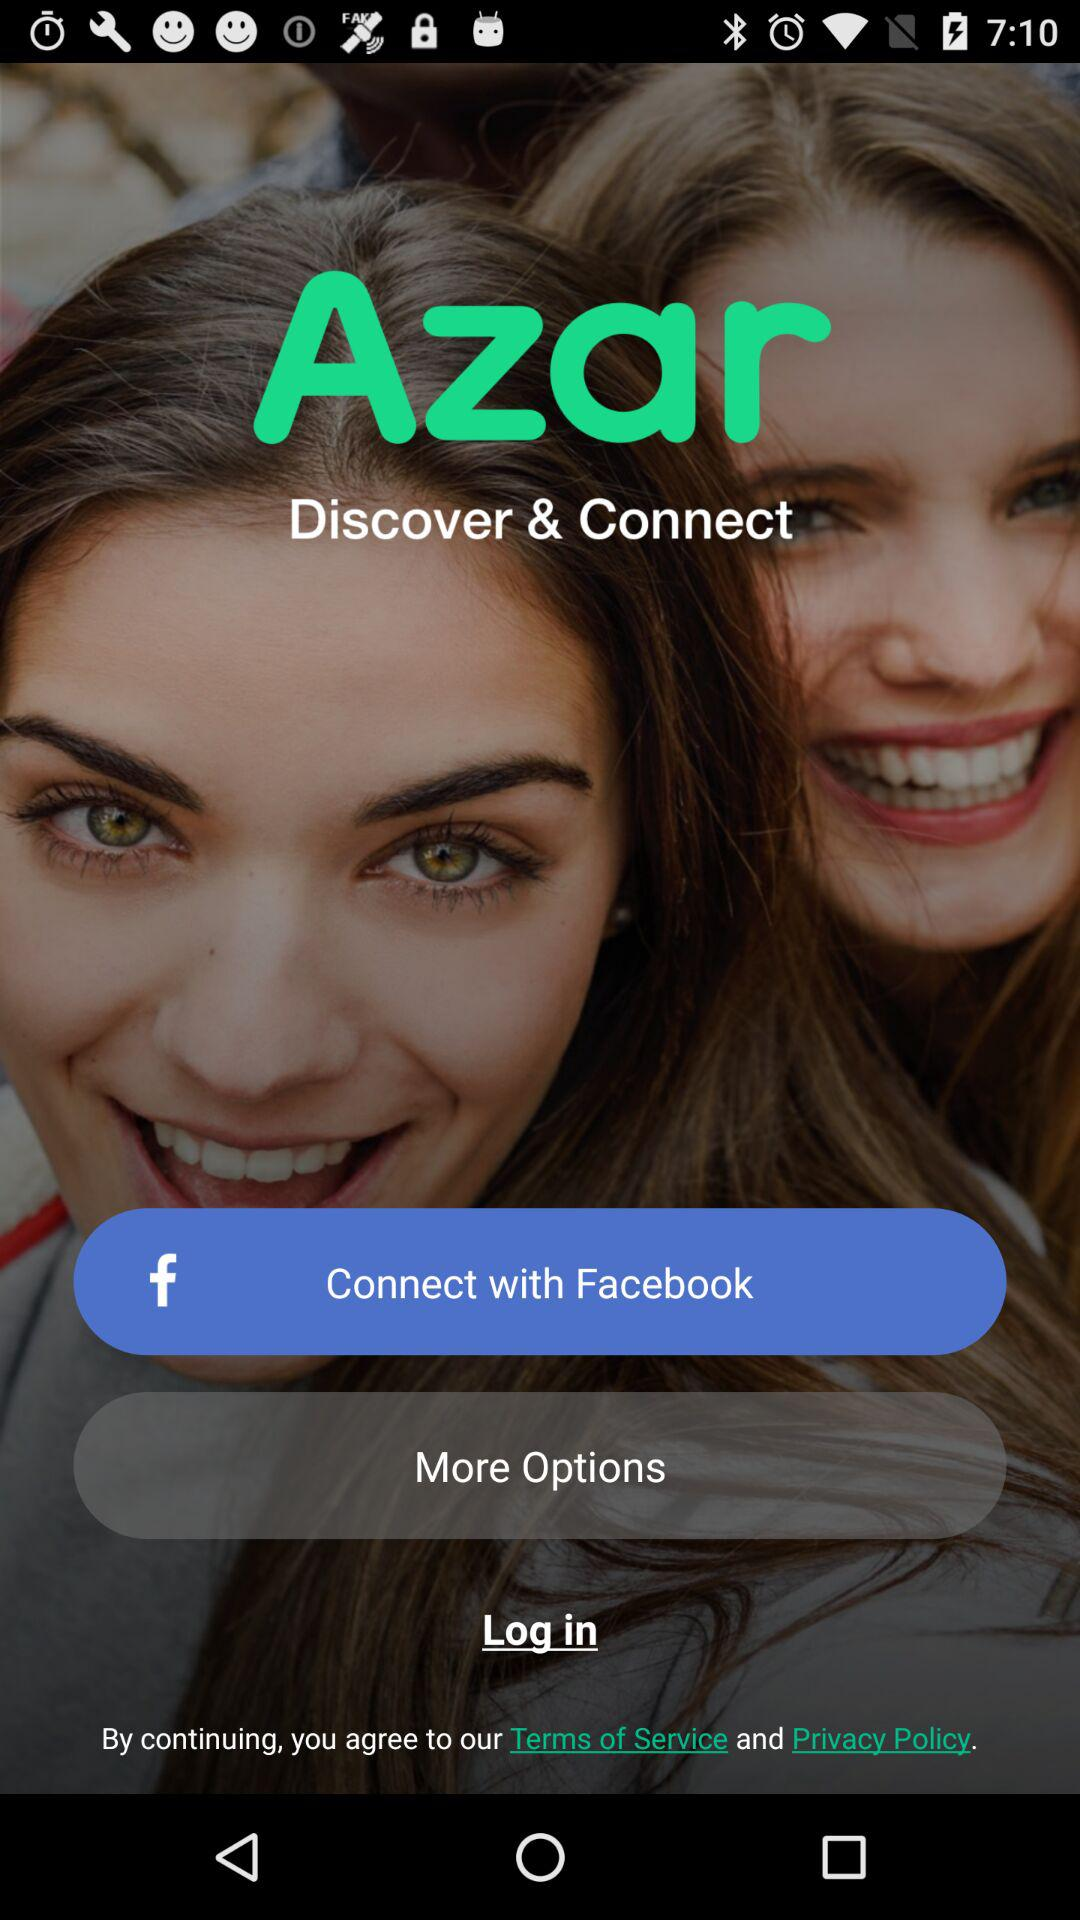What is the name of the application? The name of the application is "Azar". 